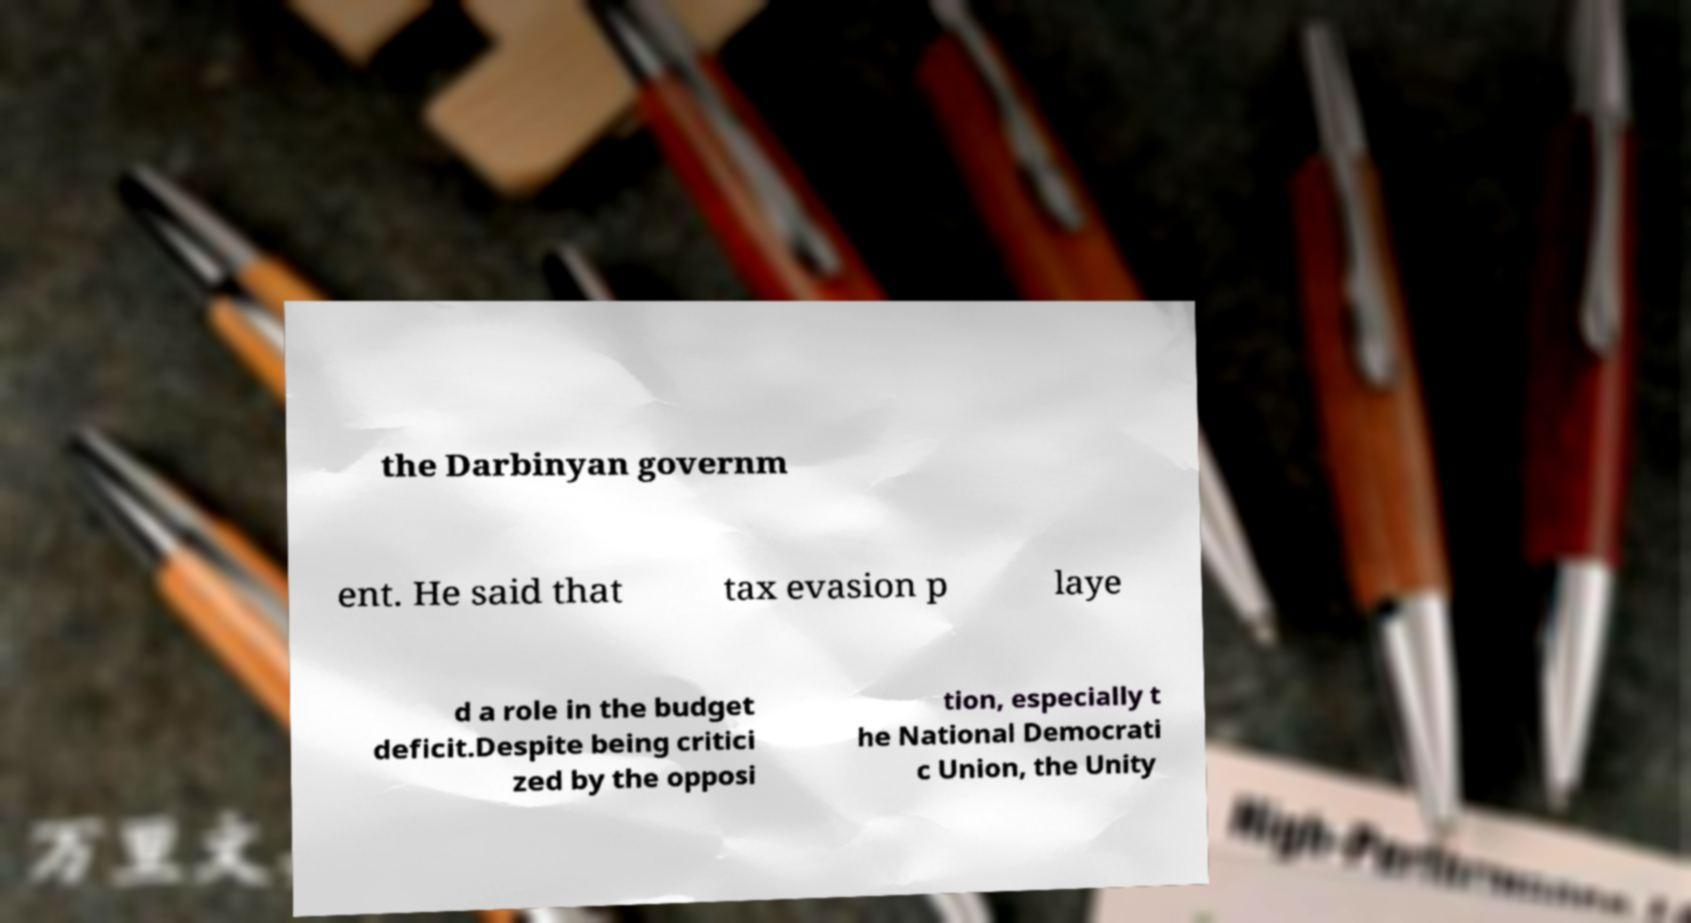There's text embedded in this image that I need extracted. Can you transcribe it verbatim? the Darbinyan governm ent. He said that tax evasion p laye d a role in the budget deficit.Despite being critici zed by the opposi tion, especially t he National Democrati c Union, the Unity 